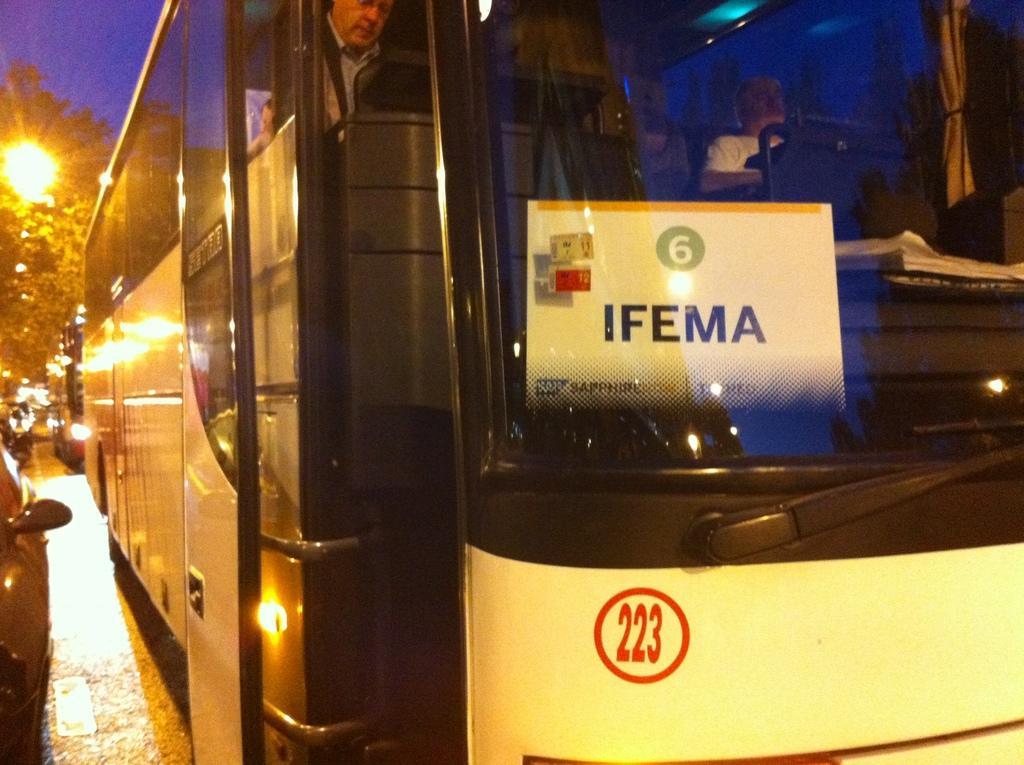How would you summarize this image in a sentence or two? In this picture we can observe a bus on the road. There is a white color board behind the windshield. We can observe a red color number on the bus. On the left side there are some vehicles on the road. In the background there is yellow color light and trees. We can observe a sky. 